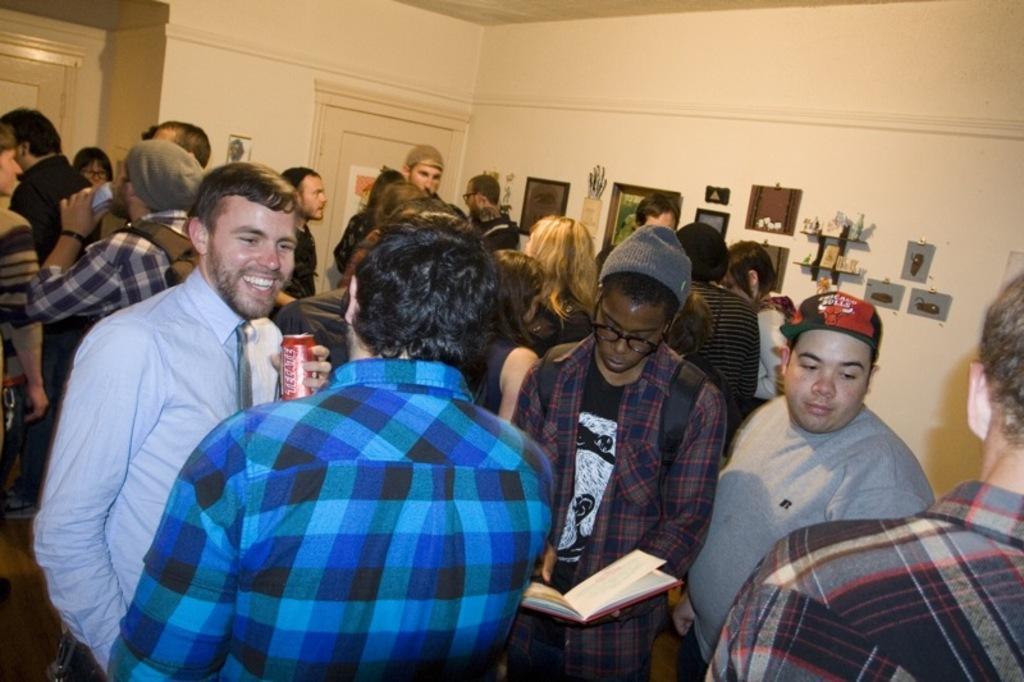Could you give a brief overview of what you see in this image? In this picture we can see some people standing here, this man is holding a book and carrying a backpack, in the background there is a wall, we can see some photo frames on the wall, there is a door here, this man is holding a tin. 